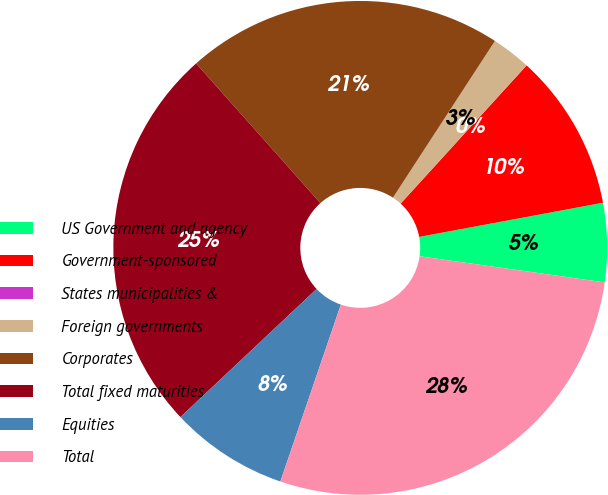Convert chart. <chart><loc_0><loc_0><loc_500><loc_500><pie_chart><fcel>US Government and agency<fcel>Government-sponsored<fcel>States municipalities &<fcel>Foreign governments<fcel>Corporates<fcel>Total fixed maturities<fcel>Equities<fcel>Total<nl><fcel>5.16%<fcel>10.31%<fcel>0.0%<fcel>2.58%<fcel>20.76%<fcel>25.44%<fcel>7.74%<fcel>28.01%<nl></chart> 